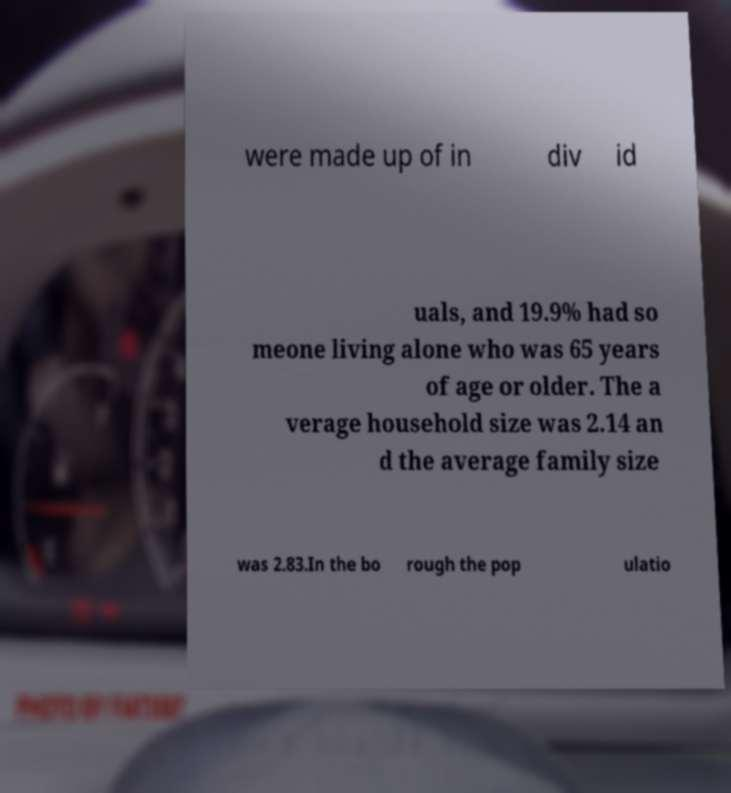I need the written content from this picture converted into text. Can you do that? were made up of in div id uals, and 19.9% had so meone living alone who was 65 years of age or older. The a verage household size was 2.14 an d the average family size was 2.83.In the bo rough the pop ulatio 